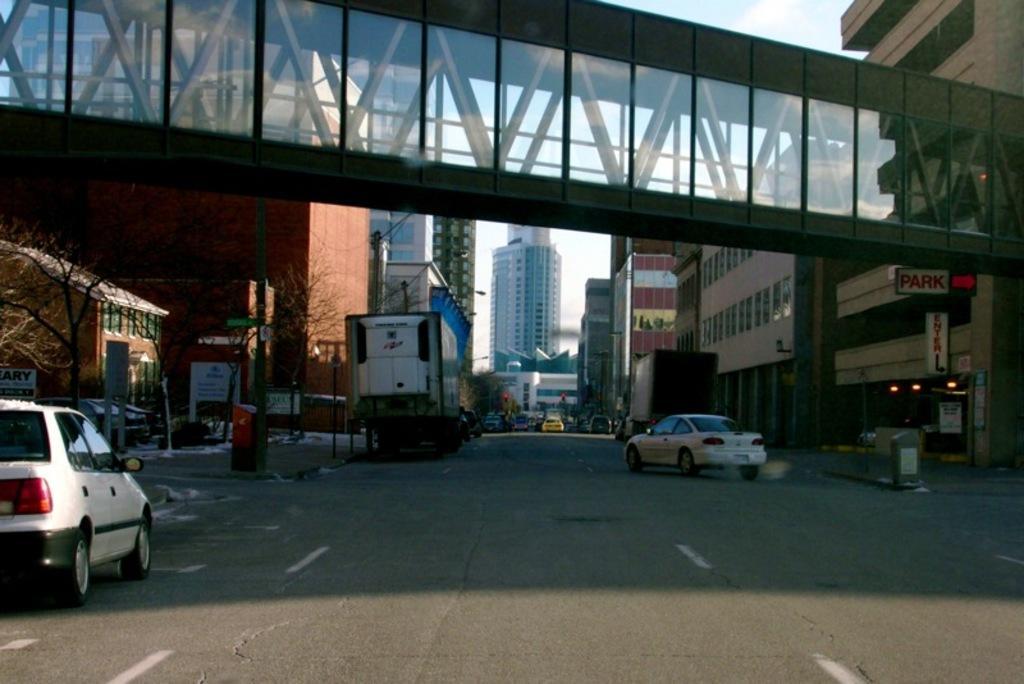Can you describe this image briefly? In the foreground I can see fleets of vehicles, fence and trees on the road. In the background I can see a bridge, light poles, buildings and the sky. This image is taken may be on the road. 